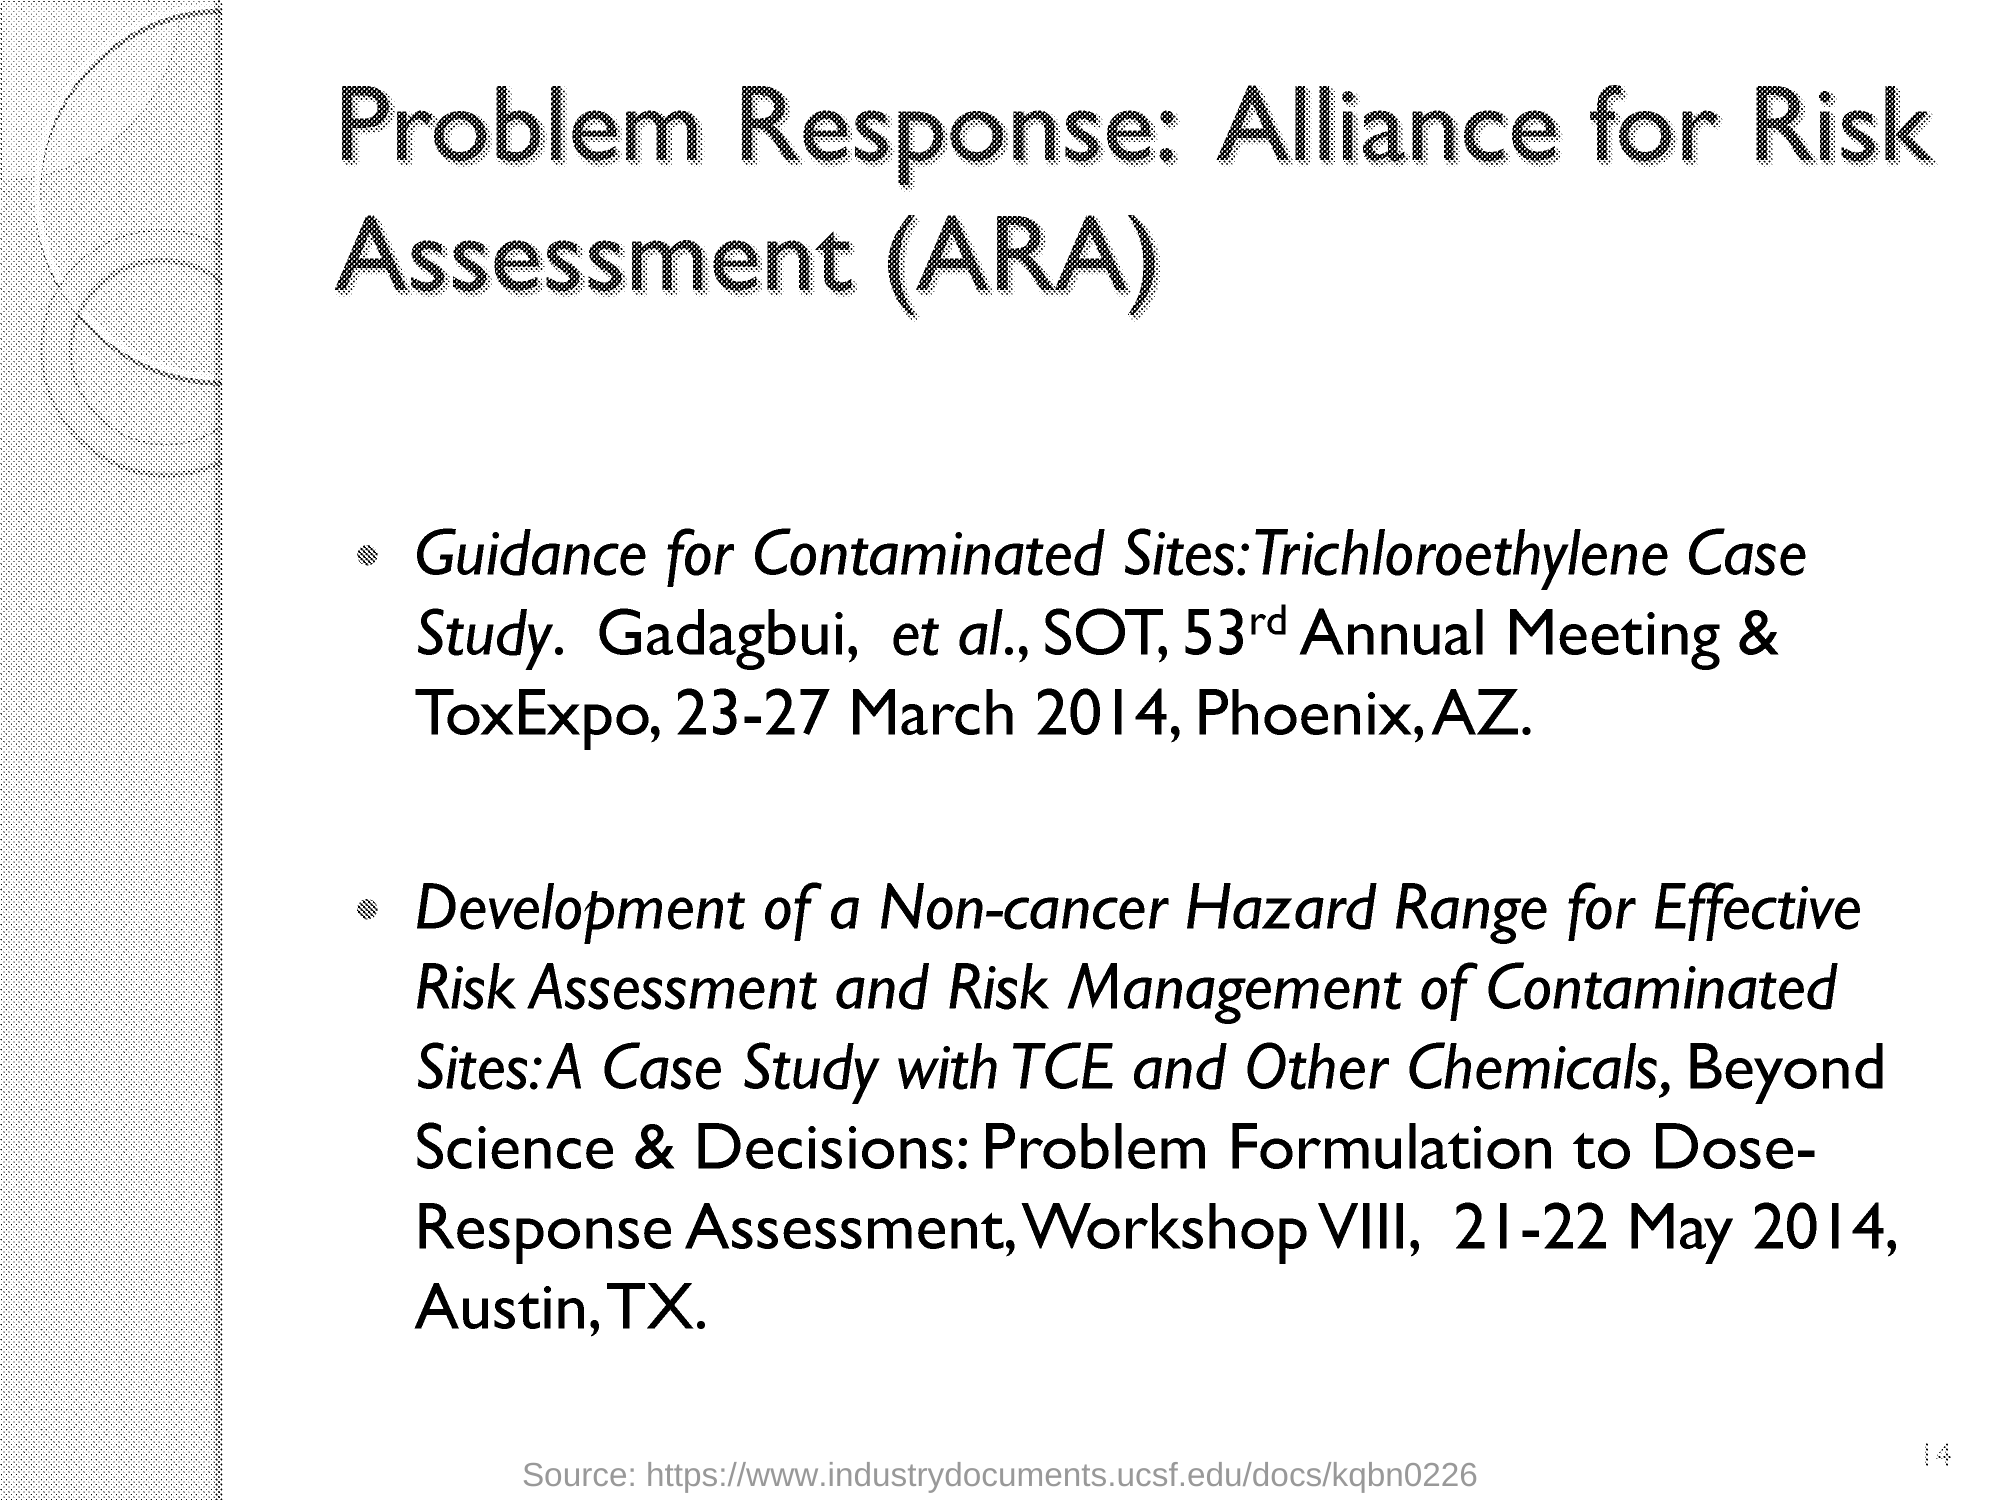What is the fullform of ARA?
Offer a terse response. Alliance for Risk Assessment. 